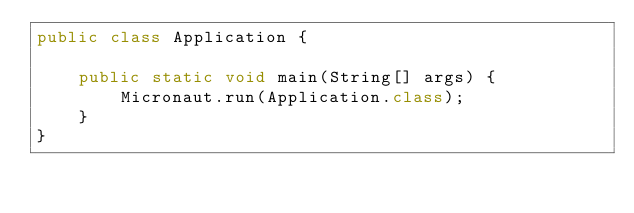Convert code to text. <code><loc_0><loc_0><loc_500><loc_500><_Java_>public class Application {

    public static void main(String[] args) {
        Micronaut.run(Application.class);
    }
}</code> 